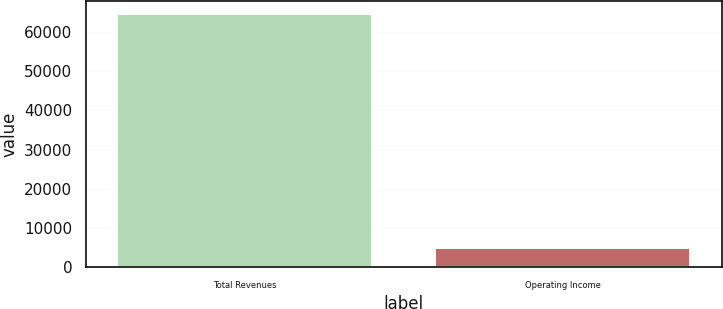Convert chart to OTSL. <chart><loc_0><loc_0><loc_500><loc_500><bar_chart><fcel>Total Revenues<fcel>Operating Income<nl><fcel>64513<fcel>4817<nl></chart> 